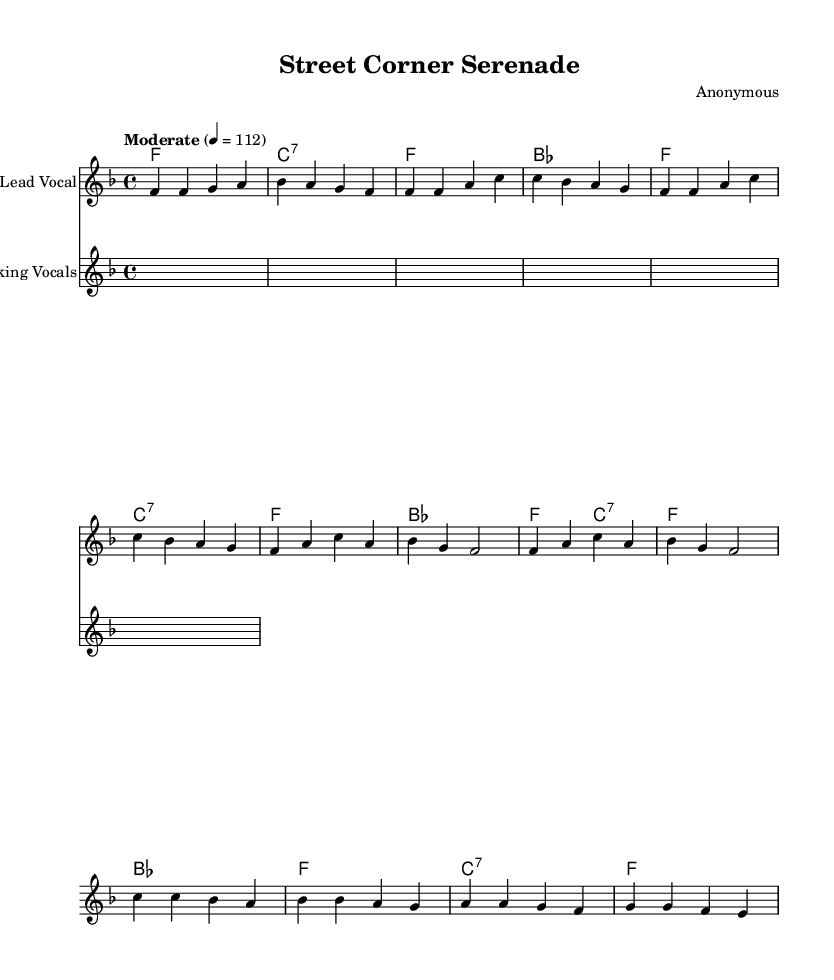What is the key signature of this music? The key signature is indicated at the beginning of the score with a flat symbol. In this case, there is one flat, which signifies F major or D minor.
Answer: F major What is the time signature of the piece? The time signature is found at the beginning of the staff and is indicated as "4/4". This means there are four beats in each measure and the quarter note gets one beat.
Answer: 4/4 What is the tempo of the piece? The tempo indication shows "Moderate" followed by a metronome mark of 112. This means the piece is to be played at a moderate speed, specifically at 112 beats per minute.
Answer: Moderate How many measures are in the chorus? The chorus section is indicated in the score and consists of 4 measures. Counting the measures marked in the score from the start of the chorus to its end confirms there are 4 distinct measures.
Answer: 4 What type of harmony is primarily used in the piece? The harmony chords follow a simple I-IV-V progression typical in doo-wop music. This means the major chords are based on the tonic (I), subdominant (IV), and dominant (V) scale degrees.
Answer: Simple harmony What are the backing vocals given in the song? The backing vocals part in the score consists of repeated syllables "doo-wop, doo-wah". This particular phrasing is characteristic of doo-wop vocal style, where non-lexical syllables are sung.
Answer: Doo-wop, doo-wah What is the structure of the song? The song's structure follows a common form with an introduction, verse, chorus, and bridge. It showcases the progression typical to many doo-wop hits with distinct sections for melodies and harmonies.
Answer: Intro, Verse, Chorus, Bridge 